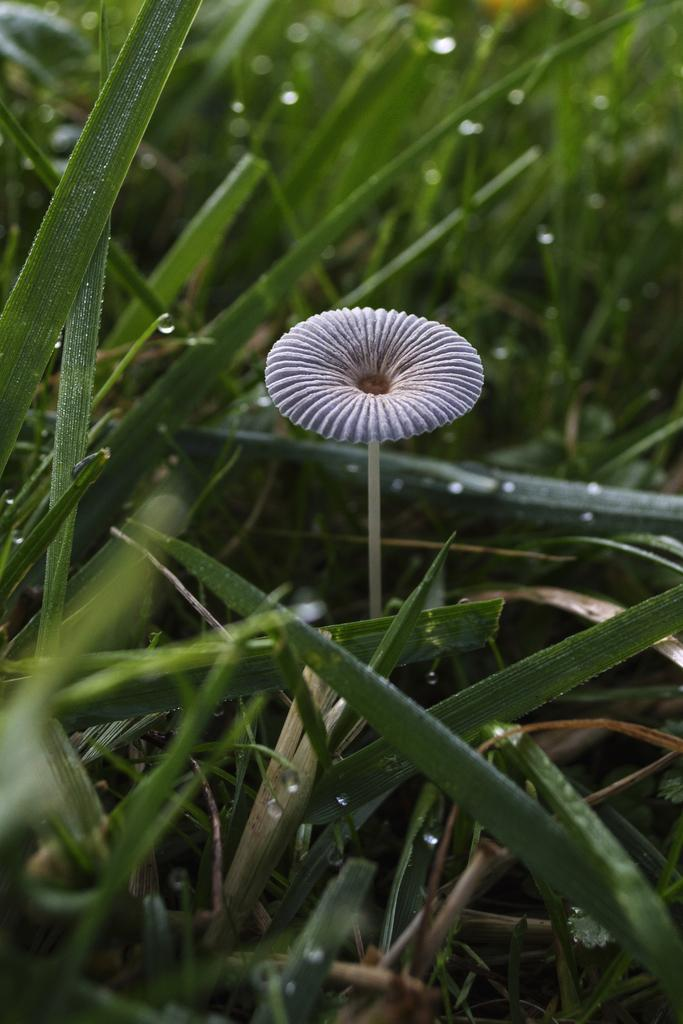What type of flower can be seen in the image? There is a purple color flower in the image. What is the color of the grass in the image? There is dew green color grass in the image. Who is the expert in the image? There is no person or expert present in the image; it features a purple flower and dew green grass. How many bits can be seen in the image? There are no bits present in the image, as it features a flower and grass. 